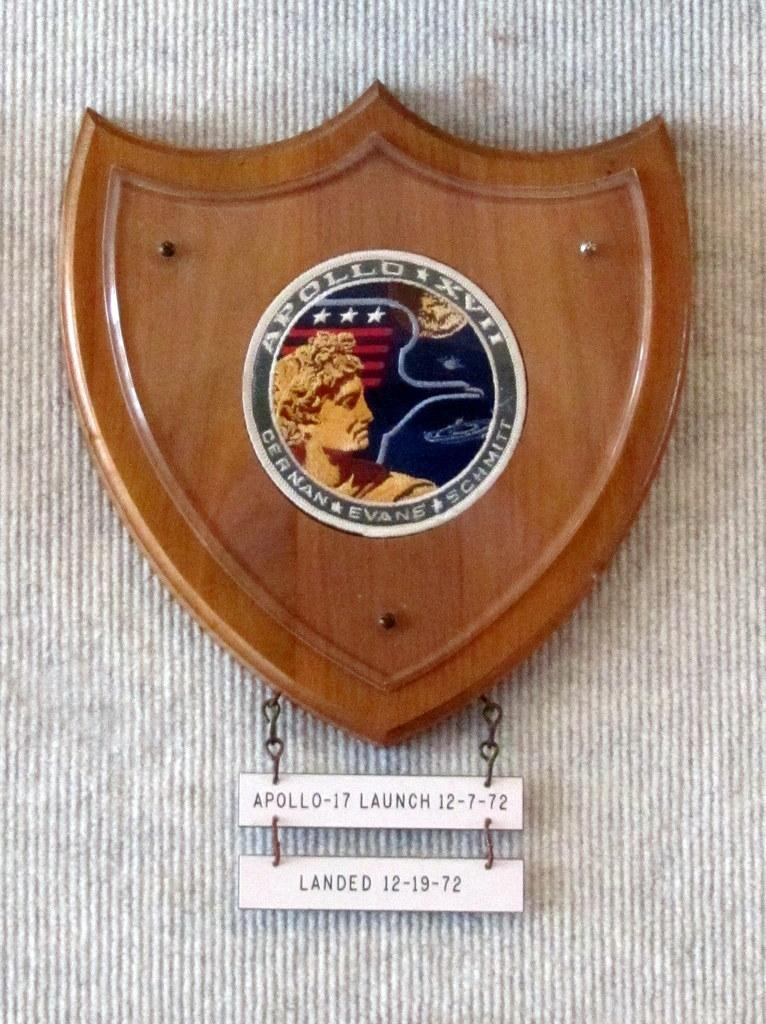What is the main subject of the image? The main subject of the image is a badge containing a space mission patch. What other items can be seen in the image? There are small boards with text written on them in the image. What is the color of the background in the image? The background of the image is grey in color. What is the beggar doing in the aftermath of the space mission in the image? There is no beggar or space mission aftermath depicted in the image; it only features a badge with a space mission patch and small boards with text. 